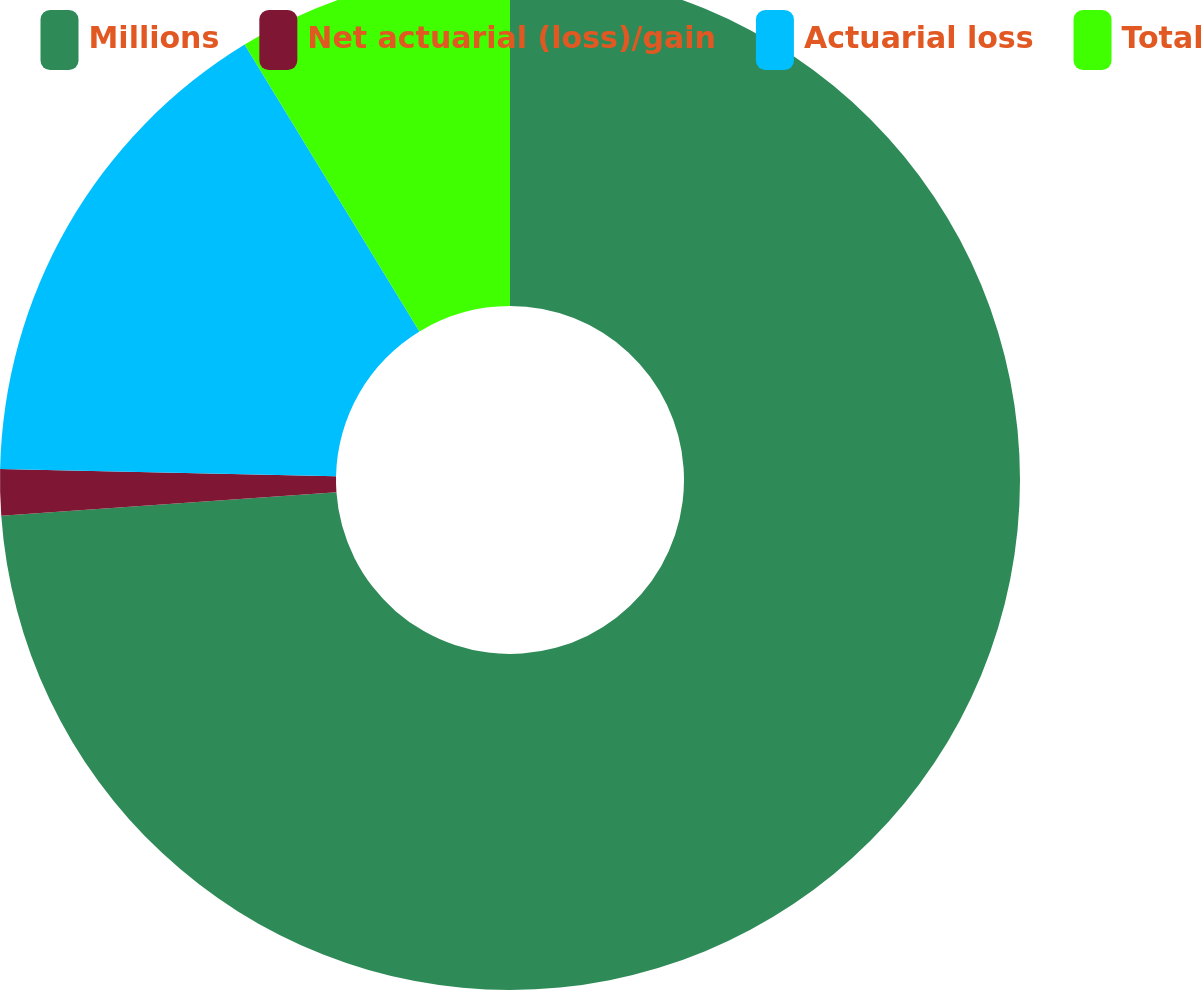Convert chart to OTSL. <chart><loc_0><loc_0><loc_500><loc_500><pie_chart><fcel>Millions<fcel>Net actuarial (loss)/gain<fcel>Actuarial loss<fcel>Total<nl><fcel>73.88%<fcel>1.46%<fcel>15.95%<fcel>8.71%<nl></chart> 